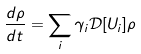<formula> <loc_0><loc_0><loc_500><loc_500>\frac { d \rho } { d t } = \sum _ { i } \gamma _ { i } \mathcal { D } [ U _ { i } ] \rho</formula> 